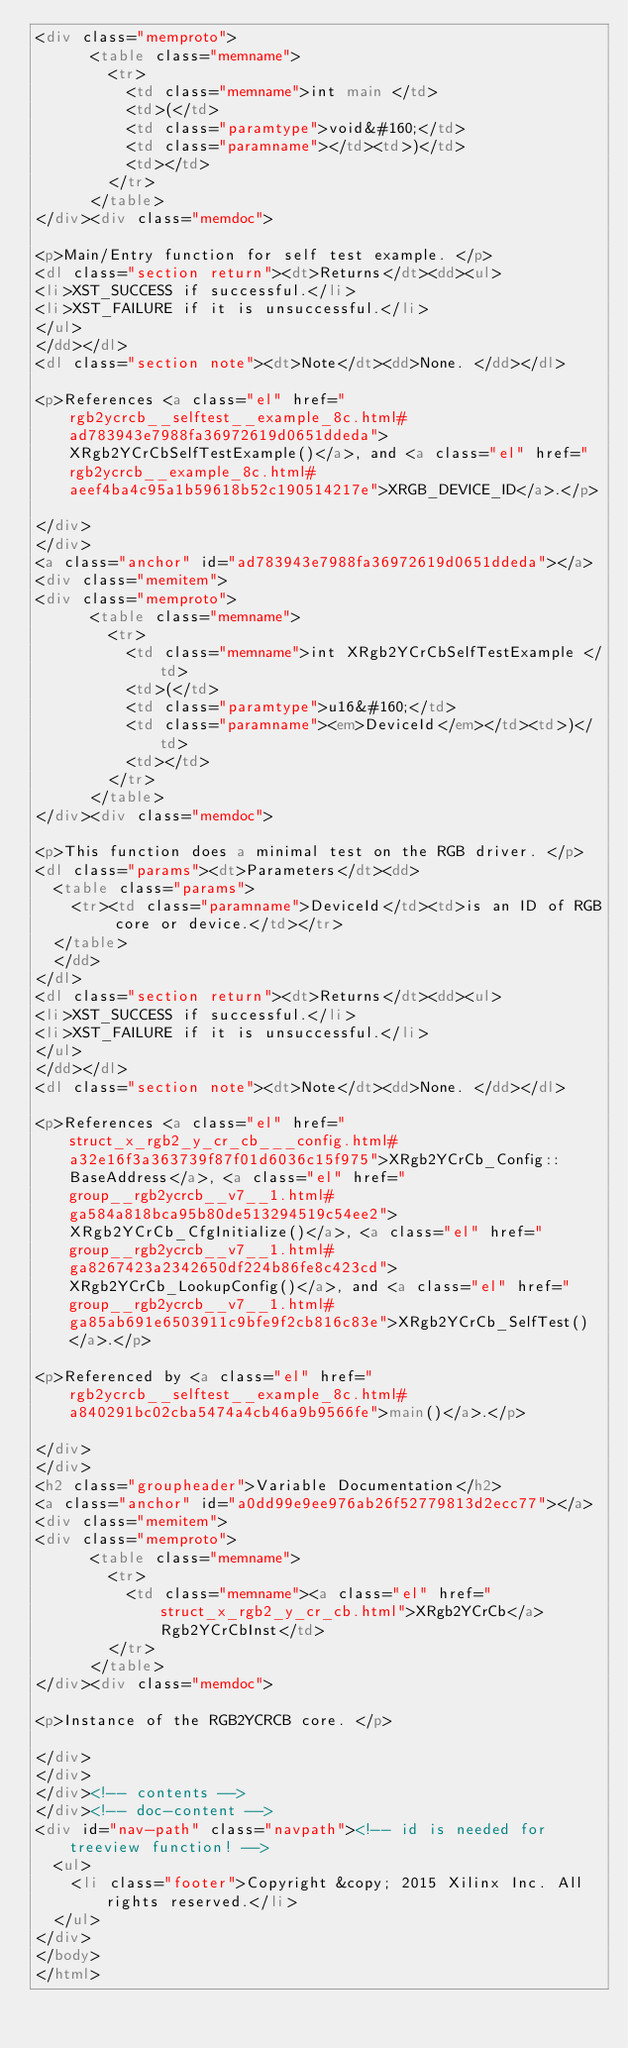Convert code to text. <code><loc_0><loc_0><loc_500><loc_500><_HTML_><div class="memproto">
      <table class="memname">
        <tr>
          <td class="memname">int main </td>
          <td>(</td>
          <td class="paramtype">void&#160;</td>
          <td class="paramname"></td><td>)</td>
          <td></td>
        </tr>
      </table>
</div><div class="memdoc">

<p>Main/Entry function for self test example. </p>
<dl class="section return"><dt>Returns</dt><dd><ul>
<li>XST_SUCCESS if successful.</li>
<li>XST_FAILURE if it is unsuccessful.</li>
</ul>
</dd></dl>
<dl class="section note"><dt>Note</dt><dd>None. </dd></dl>

<p>References <a class="el" href="rgb2ycrcb__selftest__example_8c.html#ad783943e7988fa36972619d0651ddeda">XRgb2YCrCbSelfTestExample()</a>, and <a class="el" href="rgb2ycrcb__example_8c.html#aeef4ba4c95a1b59618b52c190514217e">XRGB_DEVICE_ID</a>.</p>

</div>
</div>
<a class="anchor" id="ad783943e7988fa36972619d0651ddeda"></a>
<div class="memitem">
<div class="memproto">
      <table class="memname">
        <tr>
          <td class="memname">int XRgb2YCrCbSelfTestExample </td>
          <td>(</td>
          <td class="paramtype">u16&#160;</td>
          <td class="paramname"><em>DeviceId</em></td><td>)</td>
          <td></td>
        </tr>
      </table>
</div><div class="memdoc">

<p>This function does a minimal test on the RGB driver. </p>
<dl class="params"><dt>Parameters</dt><dd>
  <table class="params">
    <tr><td class="paramname">DeviceId</td><td>is an ID of RGB core or device.</td></tr>
  </table>
  </dd>
</dl>
<dl class="section return"><dt>Returns</dt><dd><ul>
<li>XST_SUCCESS if successful.</li>
<li>XST_FAILURE if it is unsuccessful.</li>
</ul>
</dd></dl>
<dl class="section note"><dt>Note</dt><dd>None. </dd></dl>

<p>References <a class="el" href="struct_x_rgb2_y_cr_cb___config.html#a32e16f3a363739f87f01d6036c15f975">XRgb2YCrCb_Config::BaseAddress</a>, <a class="el" href="group__rgb2ycrcb__v7__1.html#ga584a818bca95b80de513294519c54ee2">XRgb2YCrCb_CfgInitialize()</a>, <a class="el" href="group__rgb2ycrcb__v7__1.html#ga8267423a2342650df224b86fe8c423cd">XRgb2YCrCb_LookupConfig()</a>, and <a class="el" href="group__rgb2ycrcb__v7__1.html#ga85ab691e6503911c9bfe9f2cb816c83e">XRgb2YCrCb_SelfTest()</a>.</p>

<p>Referenced by <a class="el" href="rgb2ycrcb__selftest__example_8c.html#a840291bc02cba5474a4cb46a9b9566fe">main()</a>.</p>

</div>
</div>
<h2 class="groupheader">Variable Documentation</h2>
<a class="anchor" id="a0dd99e9ee976ab26f52779813d2ecc77"></a>
<div class="memitem">
<div class="memproto">
      <table class="memname">
        <tr>
          <td class="memname"><a class="el" href="struct_x_rgb2_y_cr_cb.html">XRgb2YCrCb</a> Rgb2YCrCbInst</td>
        </tr>
      </table>
</div><div class="memdoc">

<p>Instance of the RGB2YCRCB core. </p>

</div>
</div>
</div><!-- contents -->
</div><!-- doc-content -->
<div id="nav-path" class="navpath"><!-- id is needed for treeview function! -->
  <ul>
    <li class="footer">Copyright &copy; 2015 Xilinx Inc. All rights reserved.</li>
  </ul>
</div>
</body>
</html>
</code> 